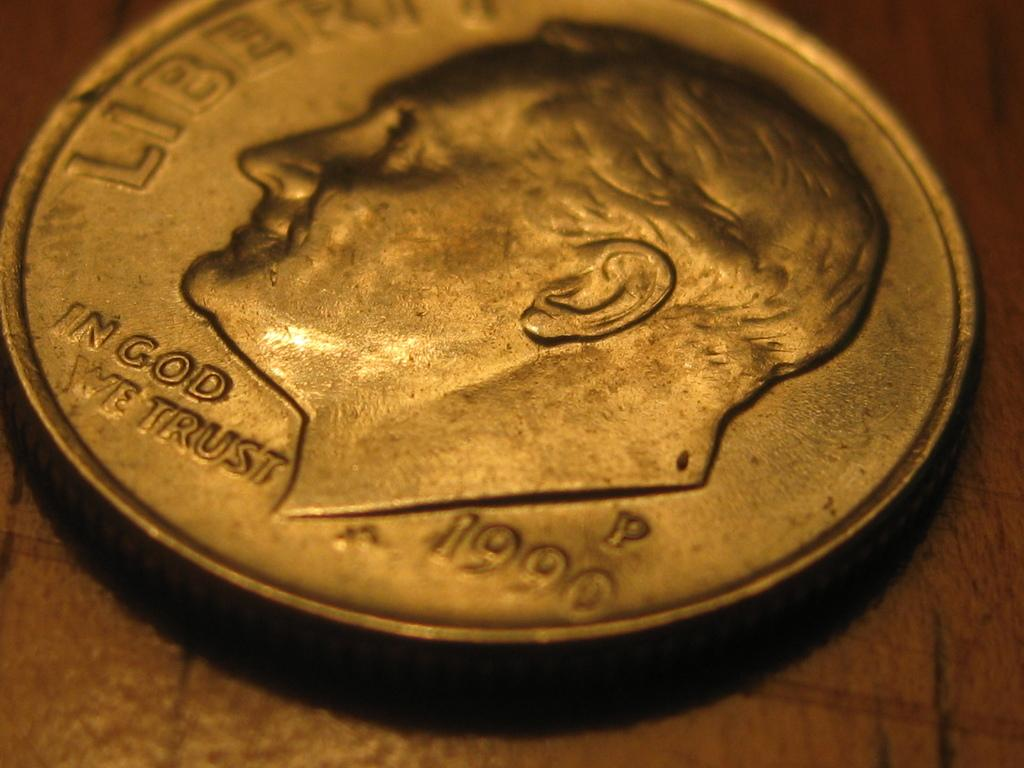Provide a one-sentence caption for the provided image. A dime shows that it is from the year 1990. 